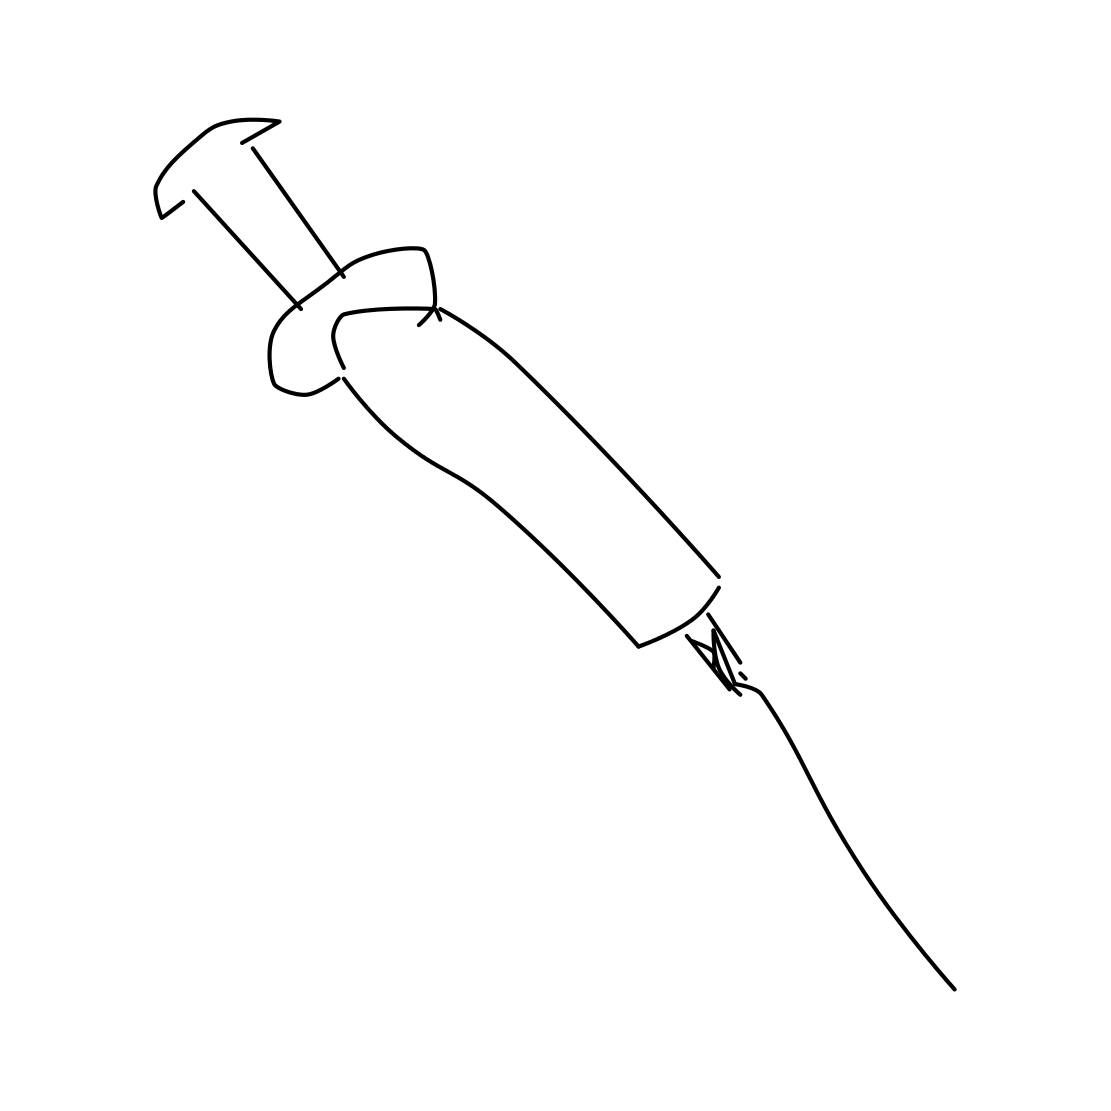Is there a sketchy syringe in the picture? Yes, the image displays a syringe that is stylized in a simplistic, sketch-like manner. It features a basic drawing of the barrel, plunger, and needle, which might be used to denote medical or other purposes in its context. 